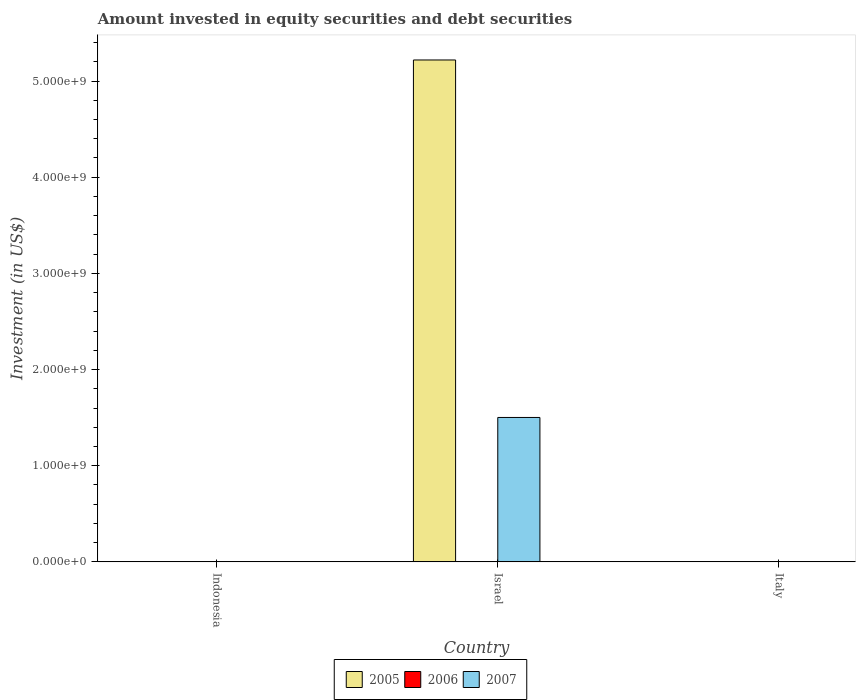How many different coloured bars are there?
Your response must be concise. 2. Are the number of bars per tick equal to the number of legend labels?
Offer a very short reply. No. How many bars are there on the 3rd tick from the left?
Your answer should be very brief. 0. In how many cases, is the number of bars for a given country not equal to the number of legend labels?
Provide a succinct answer. 3. What is the amount invested in equity securities and debt securities in 2006 in Italy?
Ensure brevity in your answer.  0. Across all countries, what is the maximum amount invested in equity securities and debt securities in 2007?
Your answer should be very brief. 1.50e+09. In which country was the amount invested in equity securities and debt securities in 2007 maximum?
Provide a succinct answer. Israel. What is the total amount invested in equity securities and debt securities in 2005 in the graph?
Give a very brief answer. 5.22e+09. What is the difference between the amount invested in equity securities and debt securities in 2005 in Israel and the amount invested in equity securities and debt securities in 2007 in Italy?
Offer a very short reply. 5.22e+09. What is the average amount invested in equity securities and debt securities in 2006 per country?
Give a very brief answer. 0. What is the difference between the amount invested in equity securities and debt securities of/in 2007 and amount invested in equity securities and debt securities of/in 2005 in Israel?
Offer a very short reply. -3.72e+09. What is the difference between the highest and the lowest amount invested in equity securities and debt securities in 2007?
Ensure brevity in your answer.  1.50e+09. In how many countries, is the amount invested in equity securities and debt securities in 2007 greater than the average amount invested in equity securities and debt securities in 2007 taken over all countries?
Keep it short and to the point. 1. Is it the case that in every country, the sum of the amount invested in equity securities and debt securities in 2007 and amount invested in equity securities and debt securities in 2006 is greater than the amount invested in equity securities and debt securities in 2005?
Your answer should be very brief. No. How many bars are there?
Your answer should be very brief. 2. Are the values on the major ticks of Y-axis written in scientific E-notation?
Provide a succinct answer. Yes. What is the title of the graph?
Give a very brief answer. Amount invested in equity securities and debt securities. What is the label or title of the X-axis?
Your answer should be compact. Country. What is the label or title of the Y-axis?
Make the answer very short. Investment (in US$). What is the Investment (in US$) in 2005 in Israel?
Provide a short and direct response. 5.22e+09. What is the Investment (in US$) in 2007 in Israel?
Give a very brief answer. 1.50e+09. What is the Investment (in US$) in 2007 in Italy?
Keep it short and to the point. 0. Across all countries, what is the maximum Investment (in US$) of 2005?
Offer a terse response. 5.22e+09. Across all countries, what is the maximum Investment (in US$) of 2007?
Keep it short and to the point. 1.50e+09. Across all countries, what is the minimum Investment (in US$) in 2005?
Provide a succinct answer. 0. What is the total Investment (in US$) in 2005 in the graph?
Offer a terse response. 5.22e+09. What is the total Investment (in US$) in 2006 in the graph?
Your response must be concise. 0. What is the total Investment (in US$) in 2007 in the graph?
Your response must be concise. 1.50e+09. What is the average Investment (in US$) in 2005 per country?
Provide a short and direct response. 1.74e+09. What is the average Investment (in US$) of 2006 per country?
Offer a terse response. 0. What is the average Investment (in US$) of 2007 per country?
Provide a short and direct response. 5.01e+08. What is the difference between the Investment (in US$) of 2005 and Investment (in US$) of 2007 in Israel?
Offer a very short reply. 3.72e+09. What is the difference between the highest and the lowest Investment (in US$) of 2005?
Provide a short and direct response. 5.22e+09. What is the difference between the highest and the lowest Investment (in US$) in 2007?
Keep it short and to the point. 1.50e+09. 